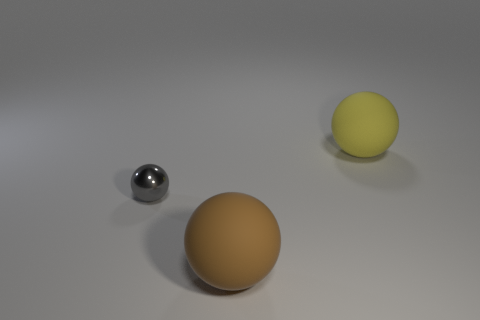Add 1 gray metallic spheres. How many objects exist? 4 Add 2 brown rubber balls. How many brown rubber balls are left? 3 Add 2 rubber objects. How many rubber objects exist? 4 Subtract 0 brown cylinders. How many objects are left? 3 Subtract all big things. Subtract all big brown matte things. How many objects are left? 0 